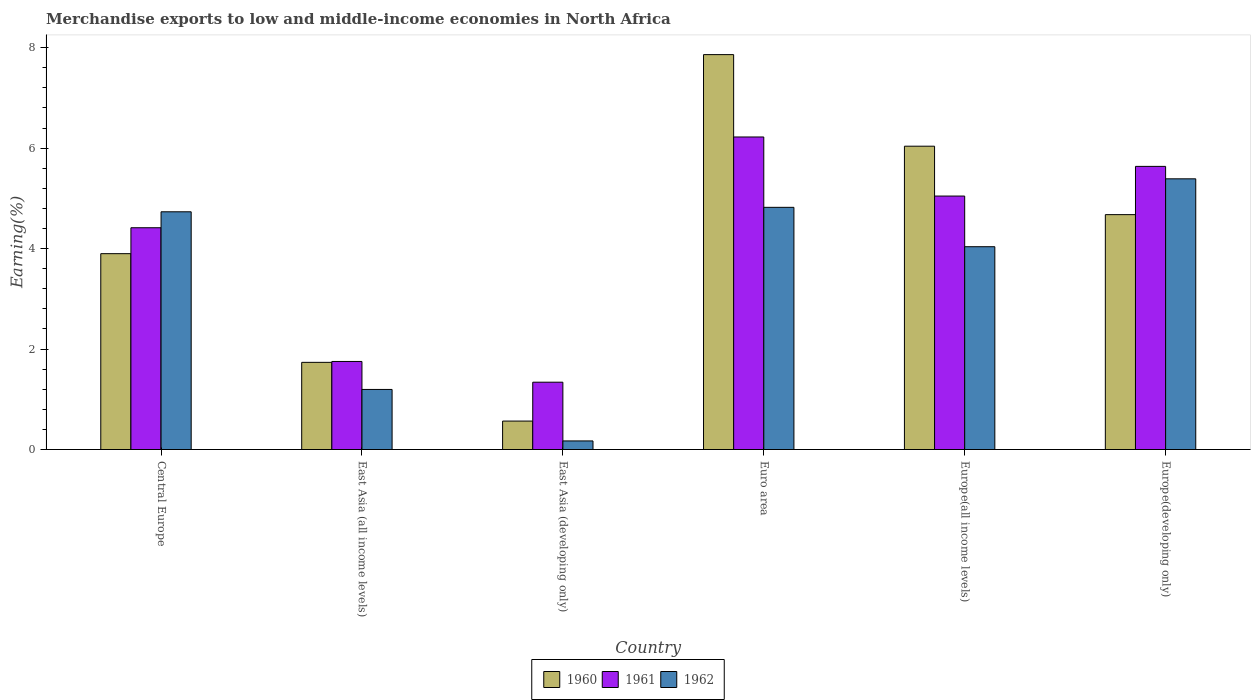Are the number of bars per tick equal to the number of legend labels?
Offer a very short reply. Yes. What is the label of the 5th group of bars from the left?
Ensure brevity in your answer.  Europe(all income levels). What is the percentage of amount earned from merchandise exports in 1962 in Europe(developing only)?
Keep it short and to the point. 5.39. Across all countries, what is the maximum percentage of amount earned from merchandise exports in 1962?
Your answer should be very brief. 5.39. Across all countries, what is the minimum percentage of amount earned from merchandise exports in 1961?
Make the answer very short. 1.34. In which country was the percentage of amount earned from merchandise exports in 1962 minimum?
Your answer should be compact. East Asia (developing only). What is the total percentage of amount earned from merchandise exports in 1962 in the graph?
Your answer should be very brief. 20.35. What is the difference between the percentage of amount earned from merchandise exports in 1961 in East Asia (all income levels) and that in Europe(all income levels)?
Your answer should be compact. -3.29. What is the difference between the percentage of amount earned from merchandise exports in 1960 in East Asia (all income levels) and the percentage of amount earned from merchandise exports in 1961 in Europe(all income levels)?
Provide a short and direct response. -3.31. What is the average percentage of amount earned from merchandise exports in 1962 per country?
Make the answer very short. 3.39. What is the difference between the percentage of amount earned from merchandise exports of/in 1961 and percentage of amount earned from merchandise exports of/in 1962 in Euro area?
Give a very brief answer. 1.4. In how many countries, is the percentage of amount earned from merchandise exports in 1962 greater than 4 %?
Provide a short and direct response. 4. What is the ratio of the percentage of amount earned from merchandise exports in 1962 in East Asia (all income levels) to that in Europe(all income levels)?
Provide a succinct answer. 0.3. Is the difference between the percentage of amount earned from merchandise exports in 1961 in East Asia (developing only) and Euro area greater than the difference between the percentage of amount earned from merchandise exports in 1962 in East Asia (developing only) and Euro area?
Provide a short and direct response. No. What is the difference between the highest and the second highest percentage of amount earned from merchandise exports in 1962?
Make the answer very short. -0.09. What is the difference between the highest and the lowest percentage of amount earned from merchandise exports in 1962?
Offer a terse response. 5.22. In how many countries, is the percentage of amount earned from merchandise exports in 1960 greater than the average percentage of amount earned from merchandise exports in 1960 taken over all countries?
Make the answer very short. 3. Is the sum of the percentage of amount earned from merchandise exports in 1962 in East Asia (developing only) and Europe(all income levels) greater than the maximum percentage of amount earned from merchandise exports in 1960 across all countries?
Provide a short and direct response. No. What does the 1st bar from the right in Central Europe represents?
Ensure brevity in your answer.  1962. Is it the case that in every country, the sum of the percentage of amount earned from merchandise exports in 1962 and percentage of amount earned from merchandise exports in 1960 is greater than the percentage of amount earned from merchandise exports in 1961?
Offer a terse response. No. How many bars are there?
Your response must be concise. 18. How many countries are there in the graph?
Keep it short and to the point. 6. What is the difference between two consecutive major ticks on the Y-axis?
Your answer should be very brief. 2. Does the graph contain grids?
Ensure brevity in your answer.  No. Where does the legend appear in the graph?
Keep it short and to the point. Bottom center. How are the legend labels stacked?
Offer a very short reply. Horizontal. What is the title of the graph?
Your response must be concise. Merchandise exports to low and middle-income economies in North Africa. Does "1984" appear as one of the legend labels in the graph?
Your answer should be compact. No. What is the label or title of the Y-axis?
Keep it short and to the point. Earning(%). What is the Earning(%) in 1960 in Central Europe?
Provide a succinct answer. 3.9. What is the Earning(%) of 1961 in Central Europe?
Keep it short and to the point. 4.42. What is the Earning(%) of 1962 in Central Europe?
Ensure brevity in your answer.  4.73. What is the Earning(%) in 1960 in East Asia (all income levels)?
Offer a very short reply. 1.74. What is the Earning(%) in 1961 in East Asia (all income levels)?
Provide a succinct answer. 1.75. What is the Earning(%) of 1962 in East Asia (all income levels)?
Your response must be concise. 1.2. What is the Earning(%) in 1960 in East Asia (developing only)?
Ensure brevity in your answer.  0.57. What is the Earning(%) of 1961 in East Asia (developing only)?
Provide a succinct answer. 1.34. What is the Earning(%) in 1962 in East Asia (developing only)?
Your response must be concise. 0.17. What is the Earning(%) in 1960 in Euro area?
Your answer should be compact. 7.86. What is the Earning(%) of 1961 in Euro area?
Your response must be concise. 6.22. What is the Earning(%) of 1962 in Euro area?
Offer a terse response. 4.82. What is the Earning(%) in 1960 in Europe(all income levels)?
Ensure brevity in your answer.  6.04. What is the Earning(%) in 1961 in Europe(all income levels)?
Your response must be concise. 5.05. What is the Earning(%) in 1962 in Europe(all income levels)?
Offer a very short reply. 4.04. What is the Earning(%) in 1960 in Europe(developing only)?
Your response must be concise. 4.68. What is the Earning(%) in 1961 in Europe(developing only)?
Your response must be concise. 5.64. What is the Earning(%) in 1962 in Europe(developing only)?
Give a very brief answer. 5.39. Across all countries, what is the maximum Earning(%) of 1960?
Your answer should be compact. 7.86. Across all countries, what is the maximum Earning(%) of 1961?
Your response must be concise. 6.22. Across all countries, what is the maximum Earning(%) in 1962?
Offer a terse response. 5.39. Across all countries, what is the minimum Earning(%) of 1960?
Ensure brevity in your answer.  0.57. Across all countries, what is the minimum Earning(%) in 1961?
Provide a short and direct response. 1.34. Across all countries, what is the minimum Earning(%) in 1962?
Offer a terse response. 0.17. What is the total Earning(%) of 1960 in the graph?
Ensure brevity in your answer.  24.78. What is the total Earning(%) in 1961 in the graph?
Your answer should be very brief. 24.42. What is the total Earning(%) in 1962 in the graph?
Your answer should be compact. 20.35. What is the difference between the Earning(%) in 1960 in Central Europe and that in East Asia (all income levels)?
Offer a terse response. 2.16. What is the difference between the Earning(%) of 1961 in Central Europe and that in East Asia (all income levels)?
Provide a succinct answer. 2.66. What is the difference between the Earning(%) of 1962 in Central Europe and that in East Asia (all income levels)?
Make the answer very short. 3.54. What is the difference between the Earning(%) in 1960 in Central Europe and that in East Asia (developing only)?
Your answer should be very brief. 3.33. What is the difference between the Earning(%) of 1961 in Central Europe and that in East Asia (developing only)?
Make the answer very short. 3.08. What is the difference between the Earning(%) of 1962 in Central Europe and that in East Asia (developing only)?
Your answer should be very brief. 4.56. What is the difference between the Earning(%) in 1960 in Central Europe and that in Euro area?
Offer a very short reply. -3.96. What is the difference between the Earning(%) of 1961 in Central Europe and that in Euro area?
Provide a succinct answer. -1.81. What is the difference between the Earning(%) in 1962 in Central Europe and that in Euro area?
Provide a short and direct response. -0.09. What is the difference between the Earning(%) of 1960 in Central Europe and that in Europe(all income levels)?
Keep it short and to the point. -2.14. What is the difference between the Earning(%) in 1961 in Central Europe and that in Europe(all income levels)?
Your answer should be compact. -0.63. What is the difference between the Earning(%) in 1962 in Central Europe and that in Europe(all income levels)?
Offer a terse response. 0.7. What is the difference between the Earning(%) of 1960 in Central Europe and that in Europe(developing only)?
Provide a short and direct response. -0.78. What is the difference between the Earning(%) in 1961 in Central Europe and that in Europe(developing only)?
Provide a succinct answer. -1.22. What is the difference between the Earning(%) of 1962 in Central Europe and that in Europe(developing only)?
Your response must be concise. -0.66. What is the difference between the Earning(%) of 1960 in East Asia (all income levels) and that in East Asia (developing only)?
Ensure brevity in your answer.  1.17. What is the difference between the Earning(%) in 1961 in East Asia (all income levels) and that in East Asia (developing only)?
Offer a very short reply. 0.41. What is the difference between the Earning(%) of 1962 in East Asia (all income levels) and that in East Asia (developing only)?
Keep it short and to the point. 1.02. What is the difference between the Earning(%) of 1960 in East Asia (all income levels) and that in Euro area?
Ensure brevity in your answer.  -6.13. What is the difference between the Earning(%) in 1961 in East Asia (all income levels) and that in Euro area?
Offer a terse response. -4.47. What is the difference between the Earning(%) of 1962 in East Asia (all income levels) and that in Euro area?
Your response must be concise. -3.63. What is the difference between the Earning(%) in 1960 in East Asia (all income levels) and that in Europe(all income levels)?
Offer a terse response. -4.3. What is the difference between the Earning(%) of 1961 in East Asia (all income levels) and that in Europe(all income levels)?
Provide a short and direct response. -3.29. What is the difference between the Earning(%) of 1962 in East Asia (all income levels) and that in Europe(all income levels)?
Offer a terse response. -2.84. What is the difference between the Earning(%) of 1960 in East Asia (all income levels) and that in Europe(developing only)?
Offer a terse response. -2.94. What is the difference between the Earning(%) of 1961 in East Asia (all income levels) and that in Europe(developing only)?
Keep it short and to the point. -3.88. What is the difference between the Earning(%) in 1962 in East Asia (all income levels) and that in Europe(developing only)?
Your answer should be very brief. -4.19. What is the difference between the Earning(%) of 1960 in East Asia (developing only) and that in Euro area?
Offer a very short reply. -7.3. What is the difference between the Earning(%) in 1961 in East Asia (developing only) and that in Euro area?
Your answer should be very brief. -4.88. What is the difference between the Earning(%) of 1962 in East Asia (developing only) and that in Euro area?
Your answer should be compact. -4.65. What is the difference between the Earning(%) in 1960 in East Asia (developing only) and that in Europe(all income levels)?
Keep it short and to the point. -5.47. What is the difference between the Earning(%) in 1961 in East Asia (developing only) and that in Europe(all income levels)?
Provide a succinct answer. -3.71. What is the difference between the Earning(%) in 1962 in East Asia (developing only) and that in Europe(all income levels)?
Make the answer very short. -3.87. What is the difference between the Earning(%) in 1960 in East Asia (developing only) and that in Europe(developing only)?
Your answer should be compact. -4.11. What is the difference between the Earning(%) in 1961 in East Asia (developing only) and that in Europe(developing only)?
Make the answer very short. -4.3. What is the difference between the Earning(%) in 1962 in East Asia (developing only) and that in Europe(developing only)?
Your response must be concise. -5.22. What is the difference between the Earning(%) in 1960 in Euro area and that in Europe(all income levels)?
Your answer should be very brief. 1.82. What is the difference between the Earning(%) of 1961 in Euro area and that in Europe(all income levels)?
Offer a terse response. 1.18. What is the difference between the Earning(%) in 1962 in Euro area and that in Europe(all income levels)?
Provide a short and direct response. 0.78. What is the difference between the Earning(%) of 1960 in Euro area and that in Europe(developing only)?
Your response must be concise. 3.19. What is the difference between the Earning(%) of 1961 in Euro area and that in Europe(developing only)?
Ensure brevity in your answer.  0.59. What is the difference between the Earning(%) in 1962 in Euro area and that in Europe(developing only)?
Offer a terse response. -0.57. What is the difference between the Earning(%) of 1960 in Europe(all income levels) and that in Europe(developing only)?
Your response must be concise. 1.36. What is the difference between the Earning(%) of 1961 in Europe(all income levels) and that in Europe(developing only)?
Ensure brevity in your answer.  -0.59. What is the difference between the Earning(%) of 1962 in Europe(all income levels) and that in Europe(developing only)?
Your answer should be very brief. -1.35. What is the difference between the Earning(%) in 1960 in Central Europe and the Earning(%) in 1961 in East Asia (all income levels)?
Your answer should be compact. 2.15. What is the difference between the Earning(%) in 1960 in Central Europe and the Earning(%) in 1962 in East Asia (all income levels)?
Offer a terse response. 2.7. What is the difference between the Earning(%) of 1961 in Central Europe and the Earning(%) of 1962 in East Asia (all income levels)?
Your response must be concise. 3.22. What is the difference between the Earning(%) in 1960 in Central Europe and the Earning(%) in 1961 in East Asia (developing only)?
Keep it short and to the point. 2.56. What is the difference between the Earning(%) of 1960 in Central Europe and the Earning(%) of 1962 in East Asia (developing only)?
Your answer should be compact. 3.73. What is the difference between the Earning(%) of 1961 in Central Europe and the Earning(%) of 1962 in East Asia (developing only)?
Make the answer very short. 4.24. What is the difference between the Earning(%) of 1960 in Central Europe and the Earning(%) of 1961 in Euro area?
Offer a very short reply. -2.32. What is the difference between the Earning(%) in 1960 in Central Europe and the Earning(%) in 1962 in Euro area?
Offer a terse response. -0.92. What is the difference between the Earning(%) of 1961 in Central Europe and the Earning(%) of 1962 in Euro area?
Offer a very short reply. -0.41. What is the difference between the Earning(%) of 1960 in Central Europe and the Earning(%) of 1961 in Europe(all income levels)?
Your answer should be very brief. -1.15. What is the difference between the Earning(%) in 1960 in Central Europe and the Earning(%) in 1962 in Europe(all income levels)?
Provide a succinct answer. -0.14. What is the difference between the Earning(%) in 1961 in Central Europe and the Earning(%) in 1962 in Europe(all income levels)?
Offer a terse response. 0.38. What is the difference between the Earning(%) in 1960 in Central Europe and the Earning(%) in 1961 in Europe(developing only)?
Your answer should be compact. -1.74. What is the difference between the Earning(%) of 1960 in Central Europe and the Earning(%) of 1962 in Europe(developing only)?
Make the answer very short. -1.49. What is the difference between the Earning(%) of 1961 in Central Europe and the Earning(%) of 1962 in Europe(developing only)?
Provide a short and direct response. -0.97. What is the difference between the Earning(%) in 1960 in East Asia (all income levels) and the Earning(%) in 1961 in East Asia (developing only)?
Your answer should be compact. 0.4. What is the difference between the Earning(%) of 1960 in East Asia (all income levels) and the Earning(%) of 1962 in East Asia (developing only)?
Your answer should be very brief. 1.56. What is the difference between the Earning(%) in 1961 in East Asia (all income levels) and the Earning(%) in 1962 in East Asia (developing only)?
Offer a terse response. 1.58. What is the difference between the Earning(%) of 1960 in East Asia (all income levels) and the Earning(%) of 1961 in Euro area?
Provide a short and direct response. -4.49. What is the difference between the Earning(%) of 1960 in East Asia (all income levels) and the Earning(%) of 1962 in Euro area?
Keep it short and to the point. -3.09. What is the difference between the Earning(%) of 1961 in East Asia (all income levels) and the Earning(%) of 1962 in Euro area?
Offer a very short reply. -3.07. What is the difference between the Earning(%) in 1960 in East Asia (all income levels) and the Earning(%) in 1961 in Europe(all income levels)?
Offer a terse response. -3.31. What is the difference between the Earning(%) in 1960 in East Asia (all income levels) and the Earning(%) in 1962 in Europe(all income levels)?
Your answer should be very brief. -2.3. What is the difference between the Earning(%) of 1961 in East Asia (all income levels) and the Earning(%) of 1962 in Europe(all income levels)?
Provide a short and direct response. -2.28. What is the difference between the Earning(%) in 1960 in East Asia (all income levels) and the Earning(%) in 1961 in Europe(developing only)?
Your answer should be compact. -3.9. What is the difference between the Earning(%) in 1960 in East Asia (all income levels) and the Earning(%) in 1962 in Europe(developing only)?
Offer a terse response. -3.65. What is the difference between the Earning(%) in 1961 in East Asia (all income levels) and the Earning(%) in 1962 in Europe(developing only)?
Provide a succinct answer. -3.64. What is the difference between the Earning(%) of 1960 in East Asia (developing only) and the Earning(%) of 1961 in Euro area?
Your answer should be compact. -5.66. What is the difference between the Earning(%) in 1960 in East Asia (developing only) and the Earning(%) in 1962 in Euro area?
Ensure brevity in your answer.  -4.26. What is the difference between the Earning(%) in 1961 in East Asia (developing only) and the Earning(%) in 1962 in Euro area?
Provide a succinct answer. -3.48. What is the difference between the Earning(%) in 1960 in East Asia (developing only) and the Earning(%) in 1961 in Europe(all income levels)?
Provide a short and direct response. -4.48. What is the difference between the Earning(%) in 1960 in East Asia (developing only) and the Earning(%) in 1962 in Europe(all income levels)?
Provide a succinct answer. -3.47. What is the difference between the Earning(%) in 1961 in East Asia (developing only) and the Earning(%) in 1962 in Europe(all income levels)?
Make the answer very short. -2.7. What is the difference between the Earning(%) in 1960 in East Asia (developing only) and the Earning(%) in 1961 in Europe(developing only)?
Ensure brevity in your answer.  -5.07. What is the difference between the Earning(%) in 1960 in East Asia (developing only) and the Earning(%) in 1962 in Europe(developing only)?
Your response must be concise. -4.82. What is the difference between the Earning(%) of 1961 in East Asia (developing only) and the Earning(%) of 1962 in Europe(developing only)?
Give a very brief answer. -4.05. What is the difference between the Earning(%) of 1960 in Euro area and the Earning(%) of 1961 in Europe(all income levels)?
Your answer should be very brief. 2.82. What is the difference between the Earning(%) in 1960 in Euro area and the Earning(%) in 1962 in Europe(all income levels)?
Provide a short and direct response. 3.82. What is the difference between the Earning(%) of 1961 in Euro area and the Earning(%) of 1962 in Europe(all income levels)?
Provide a succinct answer. 2.18. What is the difference between the Earning(%) of 1960 in Euro area and the Earning(%) of 1961 in Europe(developing only)?
Offer a terse response. 2.23. What is the difference between the Earning(%) in 1960 in Euro area and the Earning(%) in 1962 in Europe(developing only)?
Ensure brevity in your answer.  2.47. What is the difference between the Earning(%) of 1961 in Euro area and the Earning(%) of 1962 in Europe(developing only)?
Your answer should be compact. 0.83. What is the difference between the Earning(%) in 1960 in Europe(all income levels) and the Earning(%) in 1961 in Europe(developing only)?
Provide a short and direct response. 0.4. What is the difference between the Earning(%) of 1960 in Europe(all income levels) and the Earning(%) of 1962 in Europe(developing only)?
Make the answer very short. 0.65. What is the difference between the Earning(%) of 1961 in Europe(all income levels) and the Earning(%) of 1962 in Europe(developing only)?
Keep it short and to the point. -0.34. What is the average Earning(%) of 1960 per country?
Make the answer very short. 4.13. What is the average Earning(%) of 1961 per country?
Your answer should be very brief. 4.07. What is the average Earning(%) in 1962 per country?
Give a very brief answer. 3.39. What is the difference between the Earning(%) of 1960 and Earning(%) of 1961 in Central Europe?
Your answer should be very brief. -0.52. What is the difference between the Earning(%) of 1960 and Earning(%) of 1962 in Central Europe?
Make the answer very short. -0.83. What is the difference between the Earning(%) of 1961 and Earning(%) of 1962 in Central Europe?
Make the answer very short. -0.32. What is the difference between the Earning(%) of 1960 and Earning(%) of 1961 in East Asia (all income levels)?
Provide a succinct answer. -0.02. What is the difference between the Earning(%) in 1960 and Earning(%) in 1962 in East Asia (all income levels)?
Offer a very short reply. 0.54. What is the difference between the Earning(%) in 1961 and Earning(%) in 1962 in East Asia (all income levels)?
Offer a terse response. 0.56. What is the difference between the Earning(%) of 1960 and Earning(%) of 1961 in East Asia (developing only)?
Your answer should be very brief. -0.77. What is the difference between the Earning(%) in 1960 and Earning(%) in 1962 in East Asia (developing only)?
Keep it short and to the point. 0.4. What is the difference between the Earning(%) in 1961 and Earning(%) in 1962 in East Asia (developing only)?
Provide a succinct answer. 1.17. What is the difference between the Earning(%) in 1960 and Earning(%) in 1961 in Euro area?
Ensure brevity in your answer.  1.64. What is the difference between the Earning(%) of 1960 and Earning(%) of 1962 in Euro area?
Provide a short and direct response. 3.04. What is the difference between the Earning(%) in 1961 and Earning(%) in 1962 in Euro area?
Keep it short and to the point. 1.4. What is the difference between the Earning(%) of 1960 and Earning(%) of 1962 in Europe(all income levels)?
Offer a very short reply. 2. What is the difference between the Earning(%) of 1961 and Earning(%) of 1962 in Europe(all income levels)?
Your response must be concise. 1.01. What is the difference between the Earning(%) in 1960 and Earning(%) in 1961 in Europe(developing only)?
Offer a terse response. -0.96. What is the difference between the Earning(%) of 1960 and Earning(%) of 1962 in Europe(developing only)?
Provide a short and direct response. -0.71. What is the difference between the Earning(%) of 1961 and Earning(%) of 1962 in Europe(developing only)?
Give a very brief answer. 0.25. What is the ratio of the Earning(%) in 1960 in Central Europe to that in East Asia (all income levels)?
Keep it short and to the point. 2.25. What is the ratio of the Earning(%) of 1961 in Central Europe to that in East Asia (all income levels)?
Your answer should be very brief. 2.52. What is the ratio of the Earning(%) of 1962 in Central Europe to that in East Asia (all income levels)?
Ensure brevity in your answer.  3.96. What is the ratio of the Earning(%) of 1960 in Central Europe to that in East Asia (developing only)?
Offer a terse response. 6.89. What is the ratio of the Earning(%) of 1961 in Central Europe to that in East Asia (developing only)?
Provide a short and direct response. 3.29. What is the ratio of the Earning(%) of 1962 in Central Europe to that in East Asia (developing only)?
Offer a very short reply. 27.66. What is the ratio of the Earning(%) of 1960 in Central Europe to that in Euro area?
Give a very brief answer. 0.5. What is the ratio of the Earning(%) of 1961 in Central Europe to that in Euro area?
Offer a terse response. 0.71. What is the ratio of the Earning(%) in 1962 in Central Europe to that in Euro area?
Provide a short and direct response. 0.98. What is the ratio of the Earning(%) in 1960 in Central Europe to that in Europe(all income levels)?
Make the answer very short. 0.65. What is the ratio of the Earning(%) in 1961 in Central Europe to that in Europe(all income levels)?
Provide a succinct answer. 0.88. What is the ratio of the Earning(%) in 1962 in Central Europe to that in Europe(all income levels)?
Your response must be concise. 1.17. What is the ratio of the Earning(%) in 1960 in Central Europe to that in Europe(developing only)?
Ensure brevity in your answer.  0.83. What is the ratio of the Earning(%) of 1961 in Central Europe to that in Europe(developing only)?
Offer a terse response. 0.78. What is the ratio of the Earning(%) in 1962 in Central Europe to that in Europe(developing only)?
Offer a very short reply. 0.88. What is the ratio of the Earning(%) of 1960 in East Asia (all income levels) to that in East Asia (developing only)?
Keep it short and to the point. 3.06. What is the ratio of the Earning(%) in 1961 in East Asia (all income levels) to that in East Asia (developing only)?
Your answer should be very brief. 1.31. What is the ratio of the Earning(%) of 1962 in East Asia (all income levels) to that in East Asia (developing only)?
Your response must be concise. 6.99. What is the ratio of the Earning(%) in 1960 in East Asia (all income levels) to that in Euro area?
Your answer should be very brief. 0.22. What is the ratio of the Earning(%) of 1961 in East Asia (all income levels) to that in Euro area?
Provide a succinct answer. 0.28. What is the ratio of the Earning(%) in 1962 in East Asia (all income levels) to that in Euro area?
Your answer should be compact. 0.25. What is the ratio of the Earning(%) in 1960 in East Asia (all income levels) to that in Europe(all income levels)?
Offer a terse response. 0.29. What is the ratio of the Earning(%) in 1961 in East Asia (all income levels) to that in Europe(all income levels)?
Make the answer very short. 0.35. What is the ratio of the Earning(%) of 1962 in East Asia (all income levels) to that in Europe(all income levels)?
Provide a short and direct response. 0.3. What is the ratio of the Earning(%) of 1960 in East Asia (all income levels) to that in Europe(developing only)?
Keep it short and to the point. 0.37. What is the ratio of the Earning(%) of 1961 in East Asia (all income levels) to that in Europe(developing only)?
Give a very brief answer. 0.31. What is the ratio of the Earning(%) of 1962 in East Asia (all income levels) to that in Europe(developing only)?
Offer a terse response. 0.22. What is the ratio of the Earning(%) in 1960 in East Asia (developing only) to that in Euro area?
Provide a short and direct response. 0.07. What is the ratio of the Earning(%) of 1961 in East Asia (developing only) to that in Euro area?
Your answer should be very brief. 0.22. What is the ratio of the Earning(%) in 1962 in East Asia (developing only) to that in Euro area?
Provide a succinct answer. 0.04. What is the ratio of the Earning(%) of 1960 in East Asia (developing only) to that in Europe(all income levels)?
Provide a succinct answer. 0.09. What is the ratio of the Earning(%) of 1961 in East Asia (developing only) to that in Europe(all income levels)?
Make the answer very short. 0.27. What is the ratio of the Earning(%) of 1962 in East Asia (developing only) to that in Europe(all income levels)?
Offer a very short reply. 0.04. What is the ratio of the Earning(%) of 1960 in East Asia (developing only) to that in Europe(developing only)?
Provide a succinct answer. 0.12. What is the ratio of the Earning(%) in 1961 in East Asia (developing only) to that in Europe(developing only)?
Provide a short and direct response. 0.24. What is the ratio of the Earning(%) of 1962 in East Asia (developing only) to that in Europe(developing only)?
Offer a terse response. 0.03. What is the ratio of the Earning(%) of 1960 in Euro area to that in Europe(all income levels)?
Keep it short and to the point. 1.3. What is the ratio of the Earning(%) of 1961 in Euro area to that in Europe(all income levels)?
Your answer should be compact. 1.23. What is the ratio of the Earning(%) in 1962 in Euro area to that in Europe(all income levels)?
Offer a terse response. 1.19. What is the ratio of the Earning(%) in 1960 in Euro area to that in Europe(developing only)?
Offer a terse response. 1.68. What is the ratio of the Earning(%) of 1961 in Euro area to that in Europe(developing only)?
Provide a short and direct response. 1.1. What is the ratio of the Earning(%) of 1962 in Euro area to that in Europe(developing only)?
Provide a short and direct response. 0.89. What is the ratio of the Earning(%) in 1960 in Europe(all income levels) to that in Europe(developing only)?
Your response must be concise. 1.29. What is the ratio of the Earning(%) in 1961 in Europe(all income levels) to that in Europe(developing only)?
Give a very brief answer. 0.9. What is the ratio of the Earning(%) in 1962 in Europe(all income levels) to that in Europe(developing only)?
Your response must be concise. 0.75. What is the difference between the highest and the second highest Earning(%) of 1960?
Offer a terse response. 1.82. What is the difference between the highest and the second highest Earning(%) in 1961?
Provide a succinct answer. 0.59. What is the difference between the highest and the second highest Earning(%) of 1962?
Provide a short and direct response. 0.57. What is the difference between the highest and the lowest Earning(%) of 1960?
Your answer should be very brief. 7.3. What is the difference between the highest and the lowest Earning(%) of 1961?
Ensure brevity in your answer.  4.88. What is the difference between the highest and the lowest Earning(%) of 1962?
Make the answer very short. 5.22. 